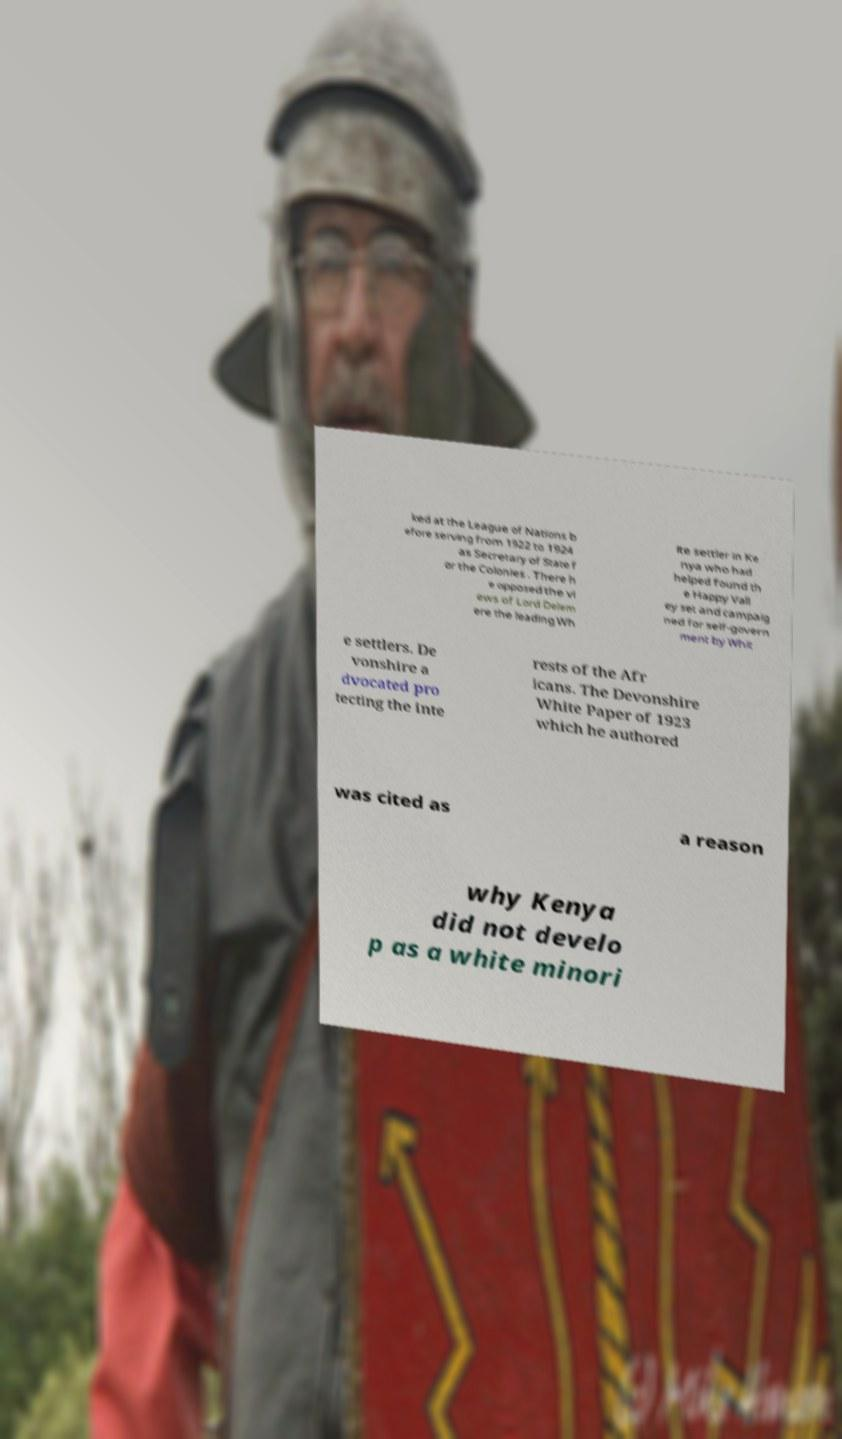For documentation purposes, I need the text within this image transcribed. Could you provide that? ked at the League of Nations b efore serving from 1922 to 1924 as Secretary of State f or the Colonies . There h e opposed the vi ews of Lord Delem ere the leading Wh ite settler in Ke nya who had helped found th e Happy Vall ey set and campaig ned for self-govern ment by Whit e settlers. De vonshire a dvocated pro tecting the inte rests of the Afr icans. The Devonshire White Paper of 1923 which he authored was cited as a reason why Kenya did not develo p as a white minori 